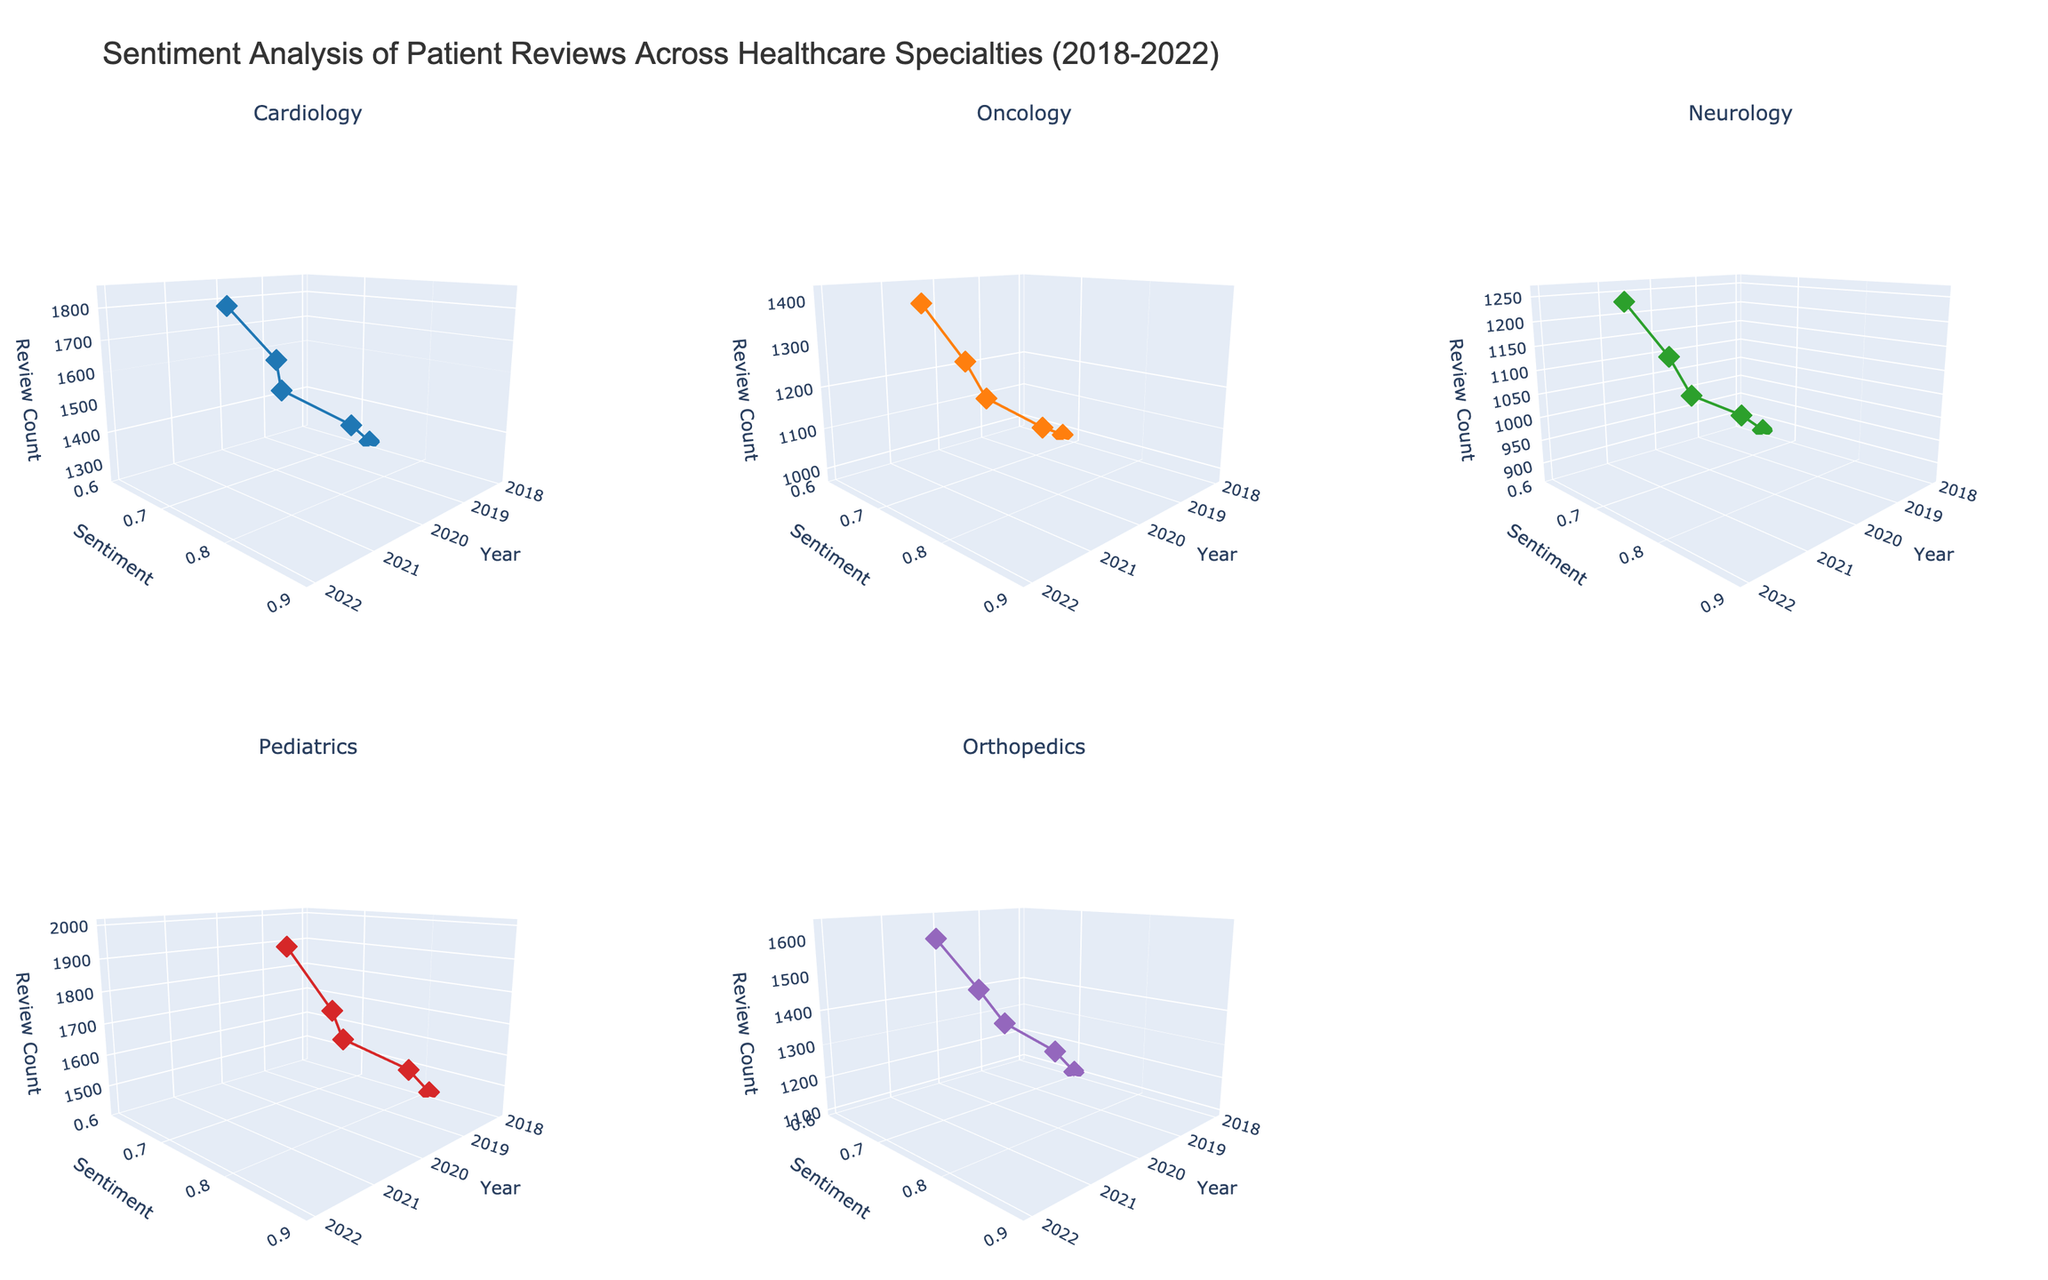What is the time range displayed in the 3D plot? The x-axis of each subplot represents the year, and from the ticks on the x-axis, we can see that the years range from 2018 to 2022.
Answer: 2018 to 2022 Which specialty has the highest sentiment score in 2022? In the Pediatrics subplot, the highest sentiment score is 0.87 in 2022.
Answer: Pediatrics How many specialties are being analyzed in the 3D plots? The subplot titles indicate there are 5 specialties: Cardiology, Oncology, Neurology, Pediatrics, and Orthopedics.
Answer: 5 Is there a specialty where the sentiment consistently increases each year from 2018 to 2022? By observing each subplot, Pediatrics shows a consistent increase in sentiment from 0.81 in 2018 to 0.87 in 2022.
Answer: Pediatrics What is the average sentiment score for Oncology across all years? Summing the sentiment scores for Oncology (0.68, 0.71, 0.69, 0.74, 0.77) gives 3.59. Dividing by 5 years, the average score is 3.59/5 = 0.718.
Answer: 0.718 Which specialty had the highest number of reviews in 2021? By looking at the z-axis (Review Count), Pediatrics has the highest number of reviews in 2021 with 1820 reviews.
Answer: Pediatrics Compare the sentiment trend of Cardiology and Neurology. Which had a greater improvement from 2018 to 2022? Cardiology started at 0.72 in 2018 and ended at 0.80 in 2022, improving by 0.08. Neurology started at 0.65 in 2018 and ended at 0.75 in 2022, improving by 0.10. Neurology had a greater improvement.
Answer: Neurology Which subplot shows the most variation in sentiment scores from 2018 to 2022? The Pediatrics subplot shows the most variation with sentiment scores ranging from 0.81 to 0.87, a difference of 0.06.
Answer: Pediatrics What is the total number of reviews for Cardiology from 2018 to 2022? Summing the review counts for Cardiology: 1250 + 1380 + 1520 + 1680 + 1850 = 7680.
Answer: 7680 In 2020, which specialty had the lowest sentiment score? In the Neuroscience subplot, the lowest sentiment score in 2020 is 0.67.
Answer: Neurology 